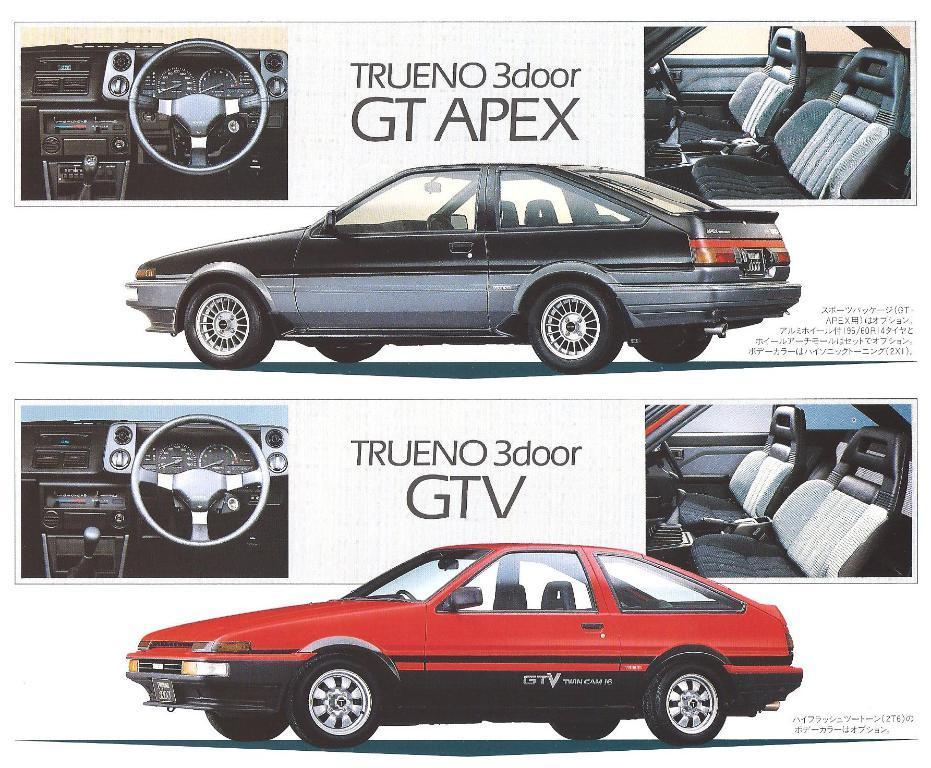Please provide a concise description of this image. In this image we can see a poster in which there are cars, text. 